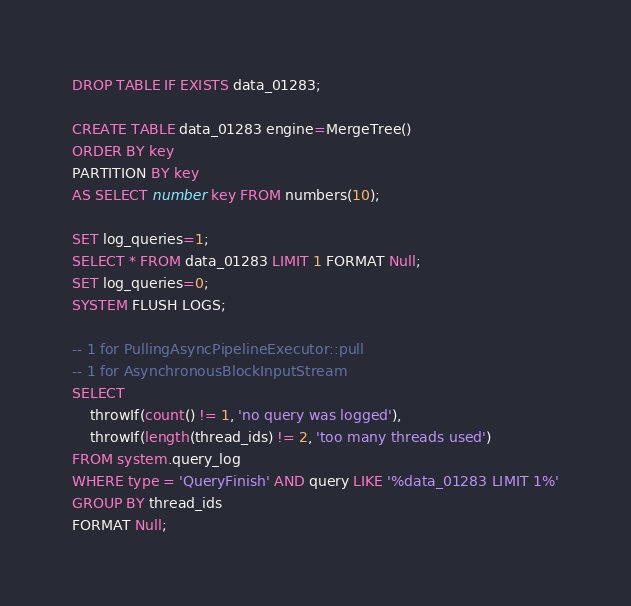<code> <loc_0><loc_0><loc_500><loc_500><_SQL_>DROP TABLE IF EXISTS data_01283;

CREATE TABLE data_01283 engine=MergeTree()
ORDER BY key
PARTITION BY key
AS SELECT number key FROM numbers(10);

SET log_queries=1;
SELECT * FROM data_01283 LIMIT 1 FORMAT Null;
SET log_queries=0;
SYSTEM FLUSH LOGS;

-- 1 for PullingAsyncPipelineExecutor::pull
-- 1 for AsynchronousBlockInputStream
SELECT
    throwIf(count() != 1, 'no query was logged'),
    throwIf(length(thread_ids) != 2, 'too many threads used')
FROM system.query_log
WHERE type = 'QueryFinish' AND query LIKE '%data_01283 LIMIT 1%'
GROUP BY thread_ids
FORMAT Null;
</code> 